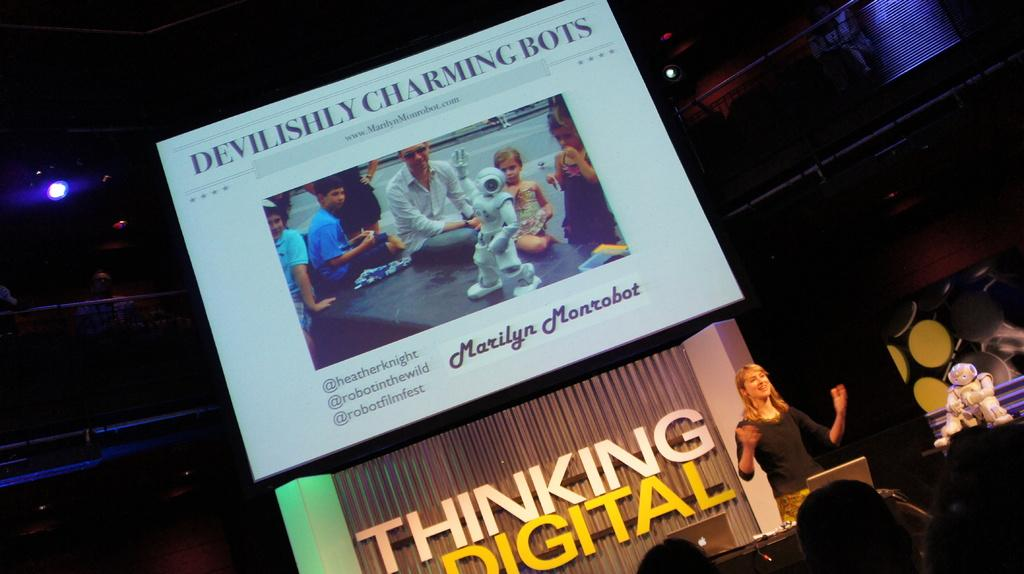<image>
Describe the image concisely. a thinking digital sign that is behind some people 